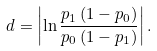<formula> <loc_0><loc_0><loc_500><loc_500>d = \left | \ln \frac { p _ { 1 } \left ( 1 - p _ { 0 } \right ) } { p _ { 0 } \left ( 1 - p _ { 1 } \right ) } \right | .</formula> 